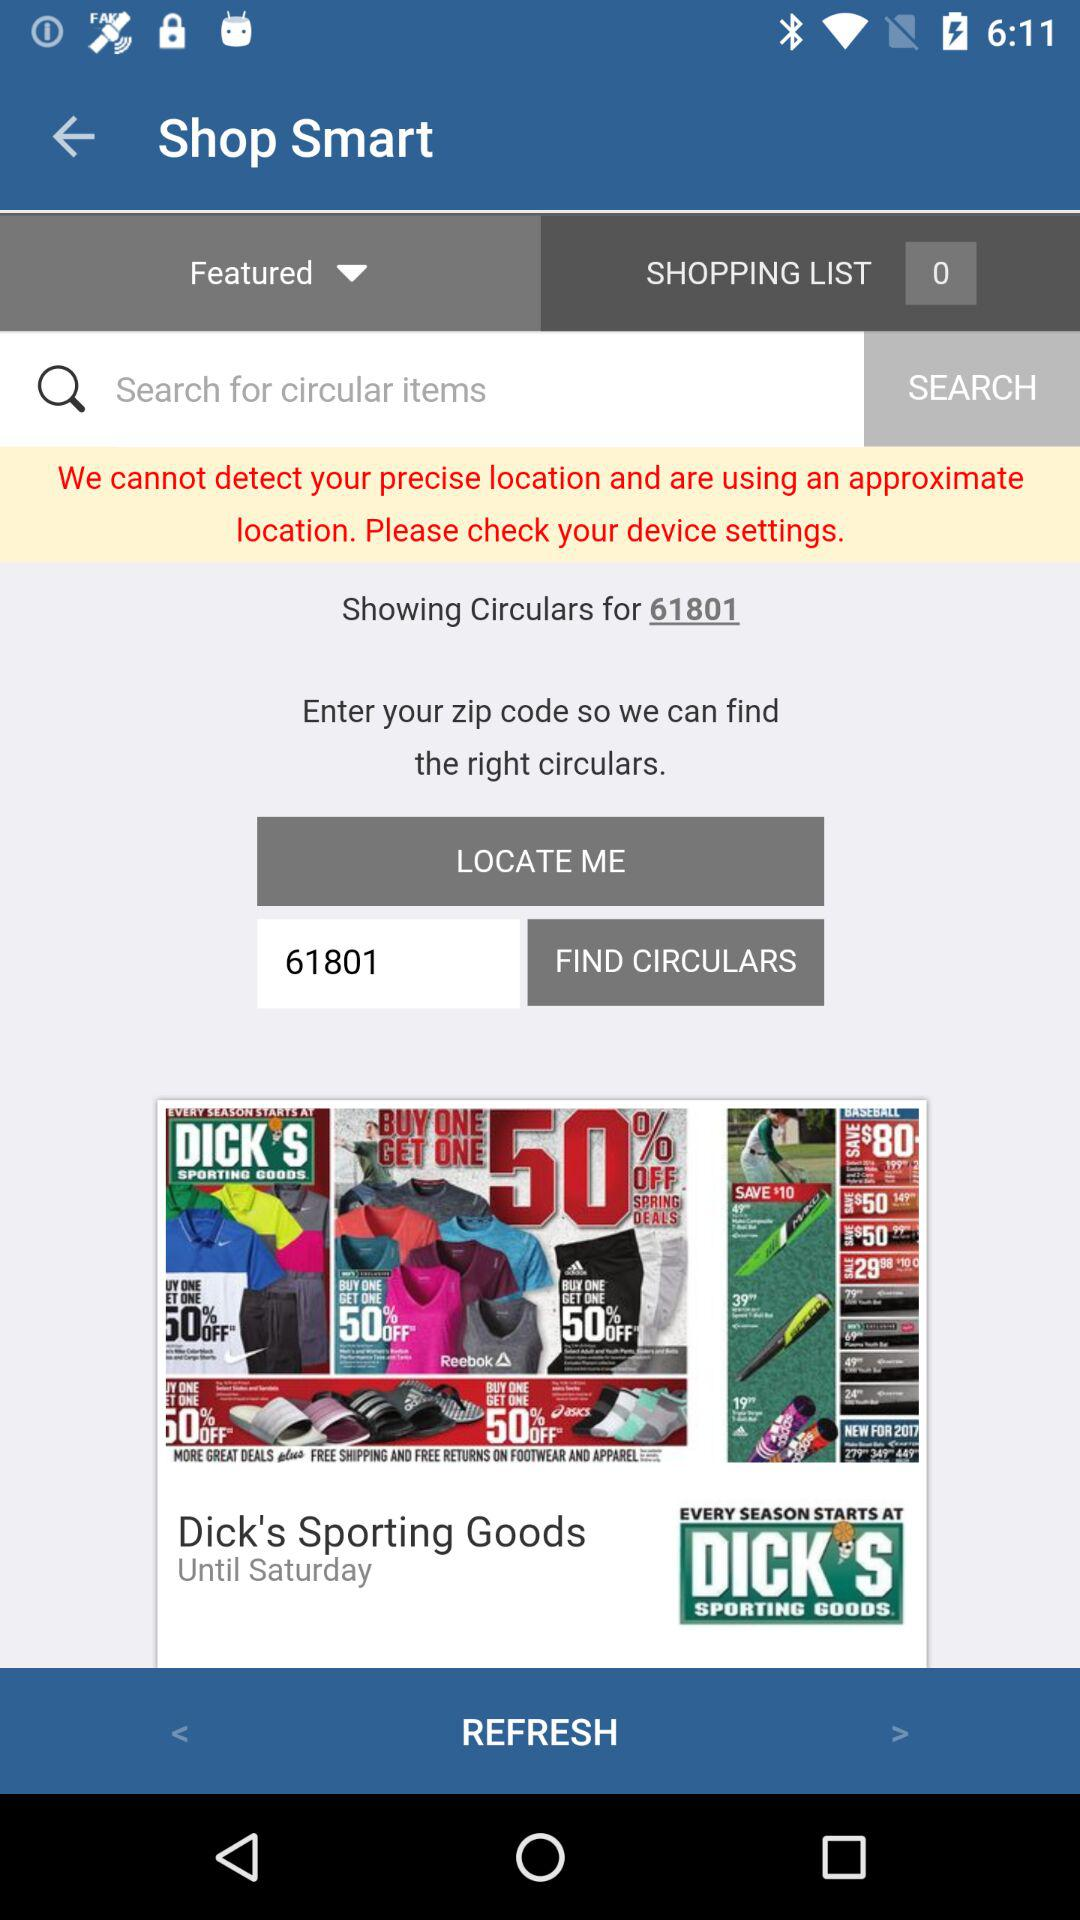How many circulars are shown for the zip code 61801?
Answer the question using a single word or phrase. 1 